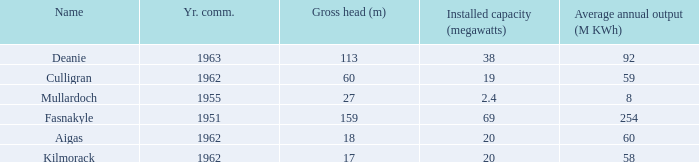What is the earliest Year commissioned wiht an Average annual output greater than 58 and Installed capacity of 20? 1962.0. 